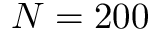Convert formula to latex. <formula><loc_0><loc_0><loc_500><loc_500>N = 2 0 0</formula> 